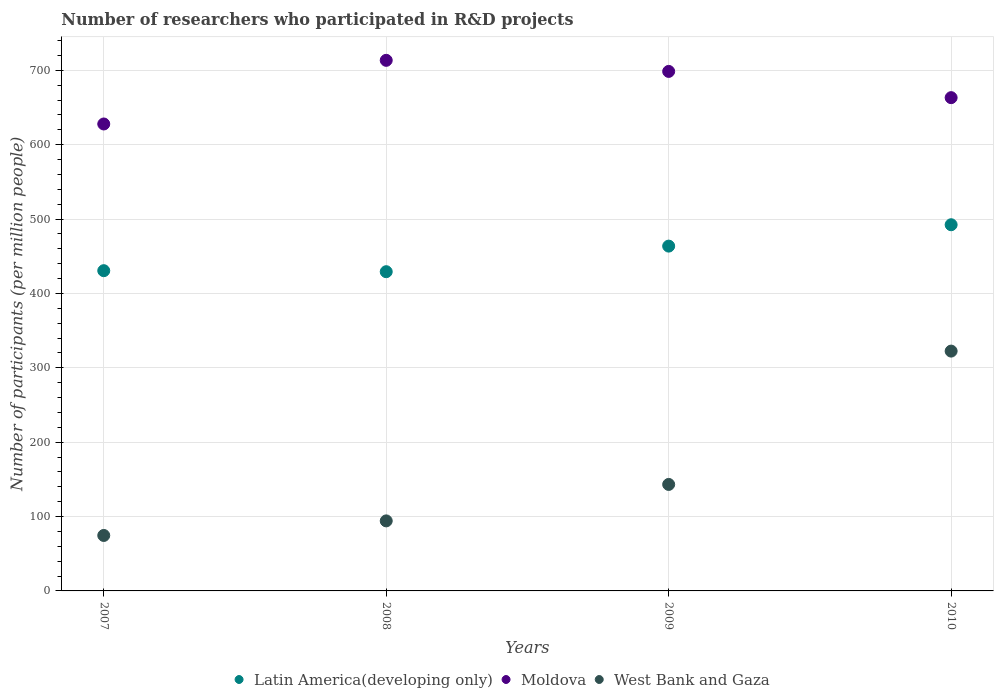Is the number of dotlines equal to the number of legend labels?
Keep it short and to the point. Yes. What is the number of researchers who participated in R&D projects in Latin America(developing only) in 2007?
Keep it short and to the point. 430.59. Across all years, what is the maximum number of researchers who participated in R&D projects in West Bank and Gaza?
Provide a succinct answer. 322.46. Across all years, what is the minimum number of researchers who participated in R&D projects in West Bank and Gaza?
Ensure brevity in your answer.  74.57. In which year was the number of researchers who participated in R&D projects in Latin America(developing only) minimum?
Your response must be concise. 2008. What is the total number of researchers who participated in R&D projects in West Bank and Gaza in the graph?
Keep it short and to the point. 634.38. What is the difference between the number of researchers who participated in R&D projects in Moldova in 2007 and that in 2008?
Make the answer very short. -85.59. What is the difference between the number of researchers who participated in R&D projects in Latin America(developing only) in 2010 and the number of researchers who participated in R&D projects in Moldova in 2007?
Offer a terse response. -135.47. What is the average number of researchers who participated in R&D projects in West Bank and Gaza per year?
Ensure brevity in your answer.  158.6. In the year 2010, what is the difference between the number of researchers who participated in R&D projects in Latin America(developing only) and number of researchers who participated in R&D projects in West Bank and Gaza?
Keep it short and to the point. 169.91. What is the ratio of the number of researchers who participated in R&D projects in West Bank and Gaza in 2008 to that in 2010?
Make the answer very short. 0.29. What is the difference between the highest and the second highest number of researchers who participated in R&D projects in Moldova?
Provide a succinct answer. 14.9. What is the difference between the highest and the lowest number of researchers who participated in R&D projects in Moldova?
Offer a terse response. 85.59. In how many years, is the number of researchers who participated in R&D projects in Latin America(developing only) greater than the average number of researchers who participated in R&D projects in Latin America(developing only) taken over all years?
Make the answer very short. 2. Is the sum of the number of researchers who participated in R&D projects in West Bank and Gaza in 2007 and 2009 greater than the maximum number of researchers who participated in R&D projects in Latin America(developing only) across all years?
Give a very brief answer. No. Does the number of researchers who participated in R&D projects in Moldova monotonically increase over the years?
Keep it short and to the point. No. How many dotlines are there?
Ensure brevity in your answer.  3. How many years are there in the graph?
Your answer should be very brief. 4. Are the values on the major ticks of Y-axis written in scientific E-notation?
Offer a very short reply. No. How many legend labels are there?
Your answer should be very brief. 3. How are the legend labels stacked?
Your answer should be very brief. Horizontal. What is the title of the graph?
Provide a succinct answer. Number of researchers who participated in R&D projects. What is the label or title of the Y-axis?
Your answer should be very brief. Number of participants (per million people). What is the Number of participants (per million people) in Latin America(developing only) in 2007?
Keep it short and to the point. 430.59. What is the Number of participants (per million people) in Moldova in 2007?
Your answer should be very brief. 627.84. What is the Number of participants (per million people) of West Bank and Gaza in 2007?
Offer a very short reply. 74.57. What is the Number of participants (per million people) in Latin America(developing only) in 2008?
Ensure brevity in your answer.  429.22. What is the Number of participants (per million people) in Moldova in 2008?
Your answer should be compact. 713.42. What is the Number of participants (per million people) in West Bank and Gaza in 2008?
Ensure brevity in your answer.  94.17. What is the Number of participants (per million people) in Latin America(developing only) in 2009?
Provide a short and direct response. 463.63. What is the Number of participants (per million people) in Moldova in 2009?
Your response must be concise. 698.52. What is the Number of participants (per million people) in West Bank and Gaza in 2009?
Give a very brief answer. 143.18. What is the Number of participants (per million people) of Latin America(developing only) in 2010?
Your response must be concise. 492.36. What is the Number of participants (per million people) in Moldova in 2010?
Make the answer very short. 663.24. What is the Number of participants (per million people) of West Bank and Gaza in 2010?
Give a very brief answer. 322.46. Across all years, what is the maximum Number of participants (per million people) of Latin America(developing only)?
Ensure brevity in your answer.  492.36. Across all years, what is the maximum Number of participants (per million people) of Moldova?
Provide a short and direct response. 713.42. Across all years, what is the maximum Number of participants (per million people) in West Bank and Gaza?
Provide a short and direct response. 322.46. Across all years, what is the minimum Number of participants (per million people) in Latin America(developing only)?
Provide a short and direct response. 429.22. Across all years, what is the minimum Number of participants (per million people) of Moldova?
Give a very brief answer. 627.84. Across all years, what is the minimum Number of participants (per million people) in West Bank and Gaza?
Provide a succinct answer. 74.57. What is the total Number of participants (per million people) in Latin America(developing only) in the graph?
Your answer should be very brief. 1815.8. What is the total Number of participants (per million people) in Moldova in the graph?
Your response must be concise. 2703.02. What is the total Number of participants (per million people) in West Bank and Gaza in the graph?
Ensure brevity in your answer.  634.38. What is the difference between the Number of participants (per million people) of Latin America(developing only) in 2007 and that in 2008?
Your answer should be compact. 1.37. What is the difference between the Number of participants (per million people) in Moldova in 2007 and that in 2008?
Give a very brief answer. -85.59. What is the difference between the Number of participants (per million people) of West Bank and Gaza in 2007 and that in 2008?
Provide a short and direct response. -19.6. What is the difference between the Number of participants (per million people) of Latin America(developing only) in 2007 and that in 2009?
Ensure brevity in your answer.  -33.04. What is the difference between the Number of participants (per million people) of Moldova in 2007 and that in 2009?
Keep it short and to the point. -70.68. What is the difference between the Number of participants (per million people) of West Bank and Gaza in 2007 and that in 2009?
Provide a succinct answer. -68.61. What is the difference between the Number of participants (per million people) of Latin America(developing only) in 2007 and that in 2010?
Make the answer very short. -61.78. What is the difference between the Number of participants (per million people) of Moldova in 2007 and that in 2010?
Your response must be concise. -35.4. What is the difference between the Number of participants (per million people) in West Bank and Gaza in 2007 and that in 2010?
Provide a short and direct response. -247.88. What is the difference between the Number of participants (per million people) of Latin America(developing only) in 2008 and that in 2009?
Ensure brevity in your answer.  -34.4. What is the difference between the Number of participants (per million people) in Moldova in 2008 and that in 2009?
Keep it short and to the point. 14.9. What is the difference between the Number of participants (per million people) of West Bank and Gaza in 2008 and that in 2009?
Your answer should be compact. -49.01. What is the difference between the Number of participants (per million people) in Latin America(developing only) in 2008 and that in 2010?
Offer a terse response. -63.14. What is the difference between the Number of participants (per million people) in Moldova in 2008 and that in 2010?
Make the answer very short. 50.18. What is the difference between the Number of participants (per million people) in West Bank and Gaza in 2008 and that in 2010?
Ensure brevity in your answer.  -228.28. What is the difference between the Number of participants (per million people) of Latin America(developing only) in 2009 and that in 2010?
Keep it short and to the point. -28.74. What is the difference between the Number of participants (per million people) in Moldova in 2009 and that in 2010?
Give a very brief answer. 35.28. What is the difference between the Number of participants (per million people) of West Bank and Gaza in 2009 and that in 2010?
Provide a short and direct response. -179.27. What is the difference between the Number of participants (per million people) of Latin America(developing only) in 2007 and the Number of participants (per million people) of Moldova in 2008?
Provide a short and direct response. -282.84. What is the difference between the Number of participants (per million people) in Latin America(developing only) in 2007 and the Number of participants (per million people) in West Bank and Gaza in 2008?
Offer a very short reply. 336.42. What is the difference between the Number of participants (per million people) of Moldova in 2007 and the Number of participants (per million people) of West Bank and Gaza in 2008?
Make the answer very short. 533.67. What is the difference between the Number of participants (per million people) of Latin America(developing only) in 2007 and the Number of participants (per million people) of Moldova in 2009?
Ensure brevity in your answer.  -267.93. What is the difference between the Number of participants (per million people) of Latin America(developing only) in 2007 and the Number of participants (per million people) of West Bank and Gaza in 2009?
Provide a short and direct response. 287.4. What is the difference between the Number of participants (per million people) in Moldova in 2007 and the Number of participants (per million people) in West Bank and Gaza in 2009?
Keep it short and to the point. 484.65. What is the difference between the Number of participants (per million people) of Latin America(developing only) in 2007 and the Number of participants (per million people) of Moldova in 2010?
Provide a short and direct response. -232.66. What is the difference between the Number of participants (per million people) in Latin America(developing only) in 2007 and the Number of participants (per million people) in West Bank and Gaza in 2010?
Offer a very short reply. 108.13. What is the difference between the Number of participants (per million people) in Moldova in 2007 and the Number of participants (per million people) in West Bank and Gaza in 2010?
Ensure brevity in your answer.  305.38. What is the difference between the Number of participants (per million people) in Latin America(developing only) in 2008 and the Number of participants (per million people) in Moldova in 2009?
Ensure brevity in your answer.  -269.3. What is the difference between the Number of participants (per million people) of Latin America(developing only) in 2008 and the Number of participants (per million people) of West Bank and Gaza in 2009?
Your answer should be very brief. 286.04. What is the difference between the Number of participants (per million people) of Moldova in 2008 and the Number of participants (per million people) of West Bank and Gaza in 2009?
Offer a terse response. 570.24. What is the difference between the Number of participants (per million people) of Latin America(developing only) in 2008 and the Number of participants (per million people) of Moldova in 2010?
Your response must be concise. -234.02. What is the difference between the Number of participants (per million people) in Latin America(developing only) in 2008 and the Number of participants (per million people) in West Bank and Gaza in 2010?
Your response must be concise. 106.77. What is the difference between the Number of participants (per million people) of Moldova in 2008 and the Number of participants (per million people) of West Bank and Gaza in 2010?
Your answer should be very brief. 390.97. What is the difference between the Number of participants (per million people) in Latin America(developing only) in 2009 and the Number of participants (per million people) in Moldova in 2010?
Your answer should be compact. -199.62. What is the difference between the Number of participants (per million people) in Latin America(developing only) in 2009 and the Number of participants (per million people) in West Bank and Gaza in 2010?
Offer a terse response. 141.17. What is the difference between the Number of participants (per million people) of Moldova in 2009 and the Number of participants (per million people) of West Bank and Gaza in 2010?
Offer a terse response. 376.06. What is the average Number of participants (per million people) of Latin America(developing only) per year?
Your answer should be very brief. 453.95. What is the average Number of participants (per million people) of Moldova per year?
Your answer should be compact. 675.75. What is the average Number of participants (per million people) in West Bank and Gaza per year?
Give a very brief answer. 158.6. In the year 2007, what is the difference between the Number of participants (per million people) in Latin America(developing only) and Number of participants (per million people) in Moldova?
Make the answer very short. -197.25. In the year 2007, what is the difference between the Number of participants (per million people) in Latin America(developing only) and Number of participants (per million people) in West Bank and Gaza?
Offer a very short reply. 356.01. In the year 2007, what is the difference between the Number of participants (per million people) of Moldova and Number of participants (per million people) of West Bank and Gaza?
Your answer should be very brief. 553.26. In the year 2008, what is the difference between the Number of participants (per million people) of Latin America(developing only) and Number of participants (per million people) of Moldova?
Ensure brevity in your answer.  -284.2. In the year 2008, what is the difference between the Number of participants (per million people) in Latin America(developing only) and Number of participants (per million people) in West Bank and Gaza?
Your answer should be compact. 335.05. In the year 2008, what is the difference between the Number of participants (per million people) in Moldova and Number of participants (per million people) in West Bank and Gaza?
Your answer should be very brief. 619.25. In the year 2009, what is the difference between the Number of participants (per million people) of Latin America(developing only) and Number of participants (per million people) of Moldova?
Your answer should be compact. -234.89. In the year 2009, what is the difference between the Number of participants (per million people) in Latin America(developing only) and Number of participants (per million people) in West Bank and Gaza?
Give a very brief answer. 320.44. In the year 2009, what is the difference between the Number of participants (per million people) in Moldova and Number of participants (per million people) in West Bank and Gaza?
Provide a short and direct response. 555.34. In the year 2010, what is the difference between the Number of participants (per million people) of Latin America(developing only) and Number of participants (per million people) of Moldova?
Your answer should be compact. -170.88. In the year 2010, what is the difference between the Number of participants (per million people) of Latin America(developing only) and Number of participants (per million people) of West Bank and Gaza?
Your answer should be very brief. 169.91. In the year 2010, what is the difference between the Number of participants (per million people) of Moldova and Number of participants (per million people) of West Bank and Gaza?
Offer a terse response. 340.79. What is the ratio of the Number of participants (per million people) of Latin America(developing only) in 2007 to that in 2008?
Provide a short and direct response. 1. What is the ratio of the Number of participants (per million people) in West Bank and Gaza in 2007 to that in 2008?
Your answer should be very brief. 0.79. What is the ratio of the Number of participants (per million people) of Latin America(developing only) in 2007 to that in 2009?
Your answer should be very brief. 0.93. What is the ratio of the Number of participants (per million people) in Moldova in 2007 to that in 2009?
Your response must be concise. 0.9. What is the ratio of the Number of participants (per million people) in West Bank and Gaza in 2007 to that in 2009?
Provide a short and direct response. 0.52. What is the ratio of the Number of participants (per million people) in Latin America(developing only) in 2007 to that in 2010?
Provide a succinct answer. 0.87. What is the ratio of the Number of participants (per million people) of Moldova in 2007 to that in 2010?
Your response must be concise. 0.95. What is the ratio of the Number of participants (per million people) in West Bank and Gaza in 2007 to that in 2010?
Offer a very short reply. 0.23. What is the ratio of the Number of participants (per million people) in Latin America(developing only) in 2008 to that in 2009?
Offer a very short reply. 0.93. What is the ratio of the Number of participants (per million people) in Moldova in 2008 to that in 2009?
Make the answer very short. 1.02. What is the ratio of the Number of participants (per million people) of West Bank and Gaza in 2008 to that in 2009?
Offer a terse response. 0.66. What is the ratio of the Number of participants (per million people) in Latin America(developing only) in 2008 to that in 2010?
Provide a succinct answer. 0.87. What is the ratio of the Number of participants (per million people) of Moldova in 2008 to that in 2010?
Your answer should be compact. 1.08. What is the ratio of the Number of participants (per million people) of West Bank and Gaza in 2008 to that in 2010?
Provide a succinct answer. 0.29. What is the ratio of the Number of participants (per million people) in Latin America(developing only) in 2009 to that in 2010?
Your answer should be compact. 0.94. What is the ratio of the Number of participants (per million people) in Moldova in 2009 to that in 2010?
Offer a very short reply. 1.05. What is the ratio of the Number of participants (per million people) in West Bank and Gaza in 2009 to that in 2010?
Make the answer very short. 0.44. What is the difference between the highest and the second highest Number of participants (per million people) in Latin America(developing only)?
Ensure brevity in your answer.  28.74. What is the difference between the highest and the second highest Number of participants (per million people) in Moldova?
Keep it short and to the point. 14.9. What is the difference between the highest and the second highest Number of participants (per million people) of West Bank and Gaza?
Your answer should be compact. 179.27. What is the difference between the highest and the lowest Number of participants (per million people) in Latin America(developing only)?
Offer a terse response. 63.14. What is the difference between the highest and the lowest Number of participants (per million people) of Moldova?
Ensure brevity in your answer.  85.59. What is the difference between the highest and the lowest Number of participants (per million people) of West Bank and Gaza?
Make the answer very short. 247.88. 